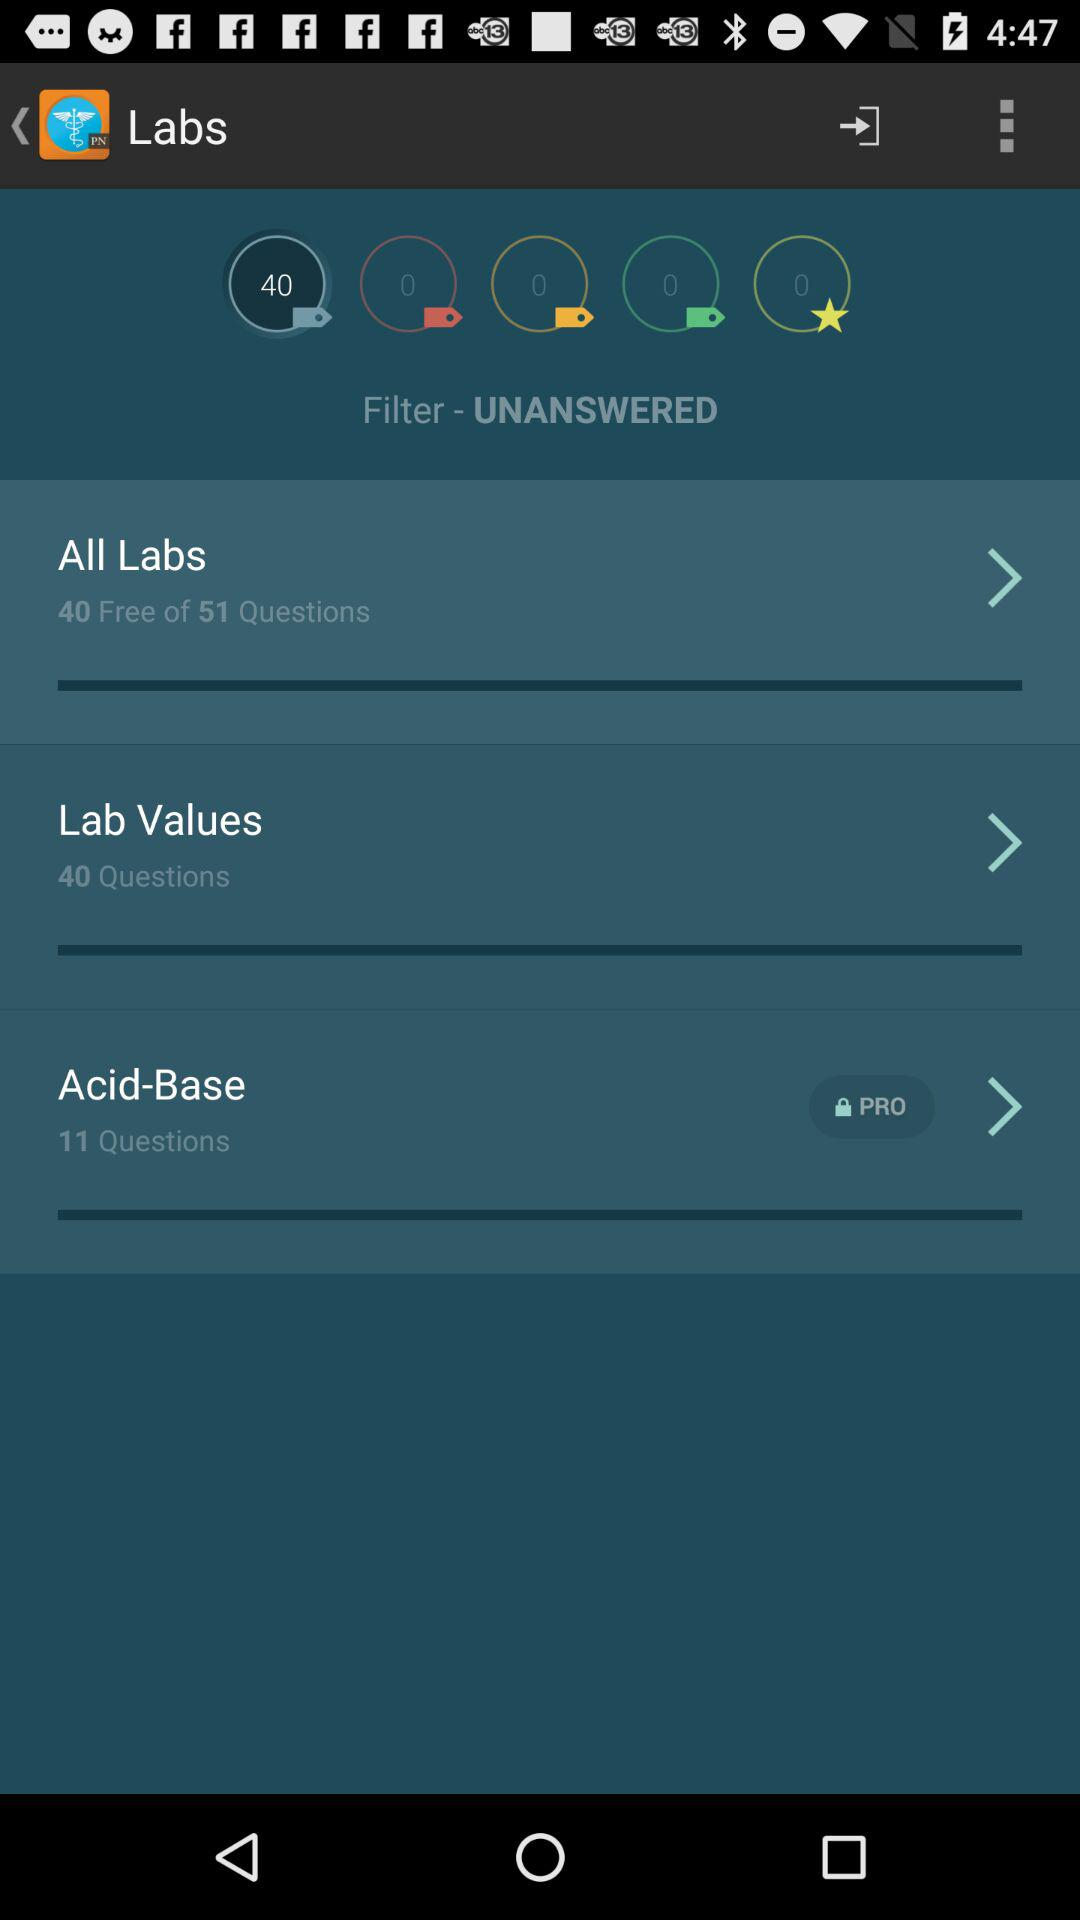How many questions are free?
Answer the question using a single word or phrase. 40 